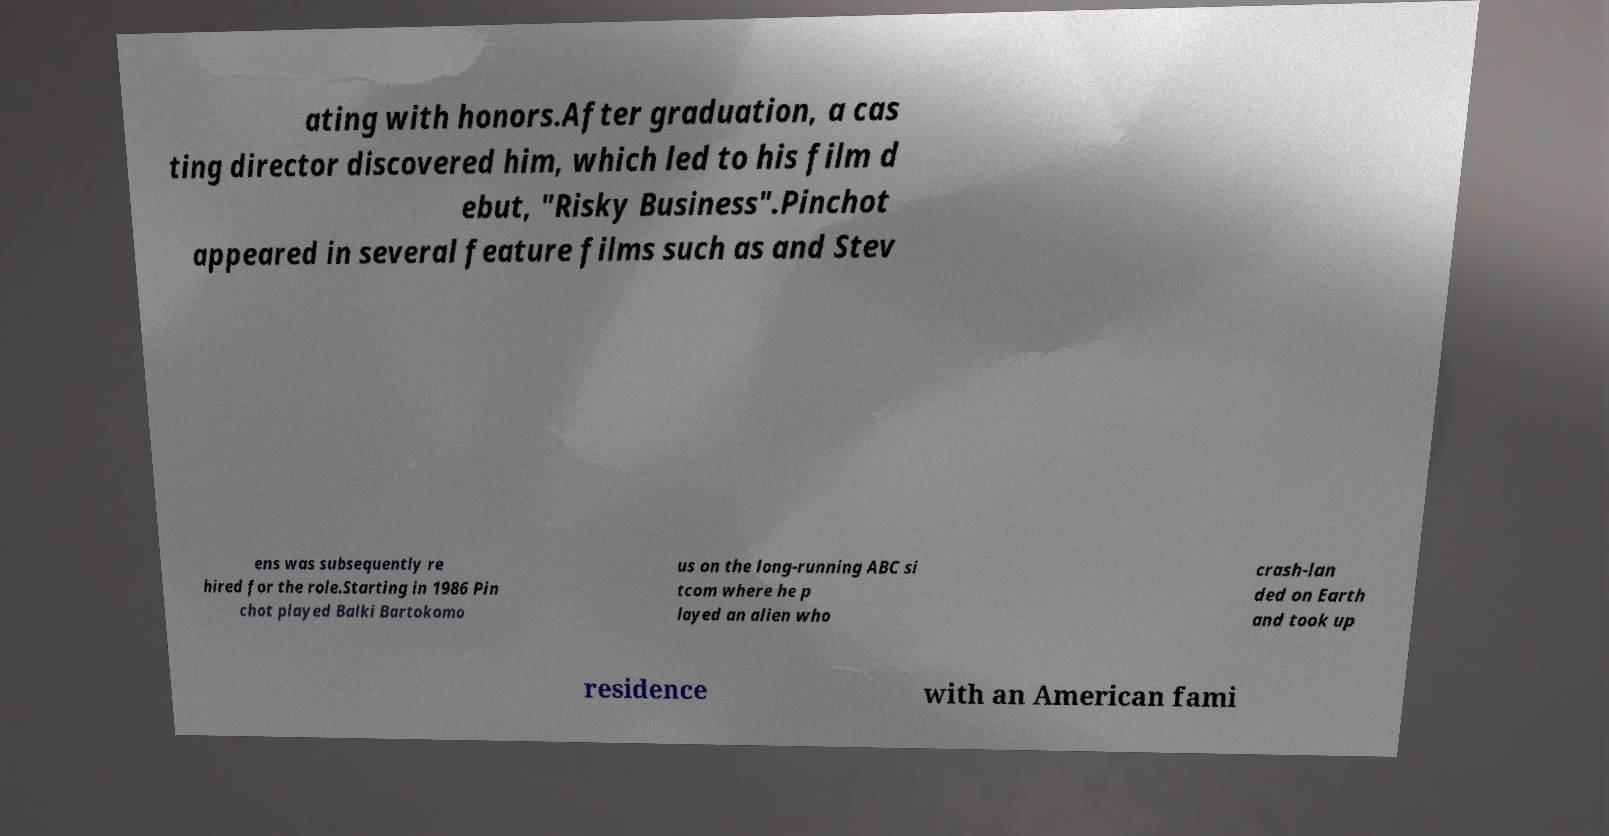Could you extract and type out the text from this image? ating with honors.After graduation, a cas ting director discovered him, which led to his film d ebut, "Risky Business".Pinchot appeared in several feature films such as and Stev ens was subsequently re hired for the role.Starting in 1986 Pin chot played Balki Bartokomo us on the long-running ABC si tcom where he p layed an alien who crash-lan ded on Earth and took up residence with an American fami 